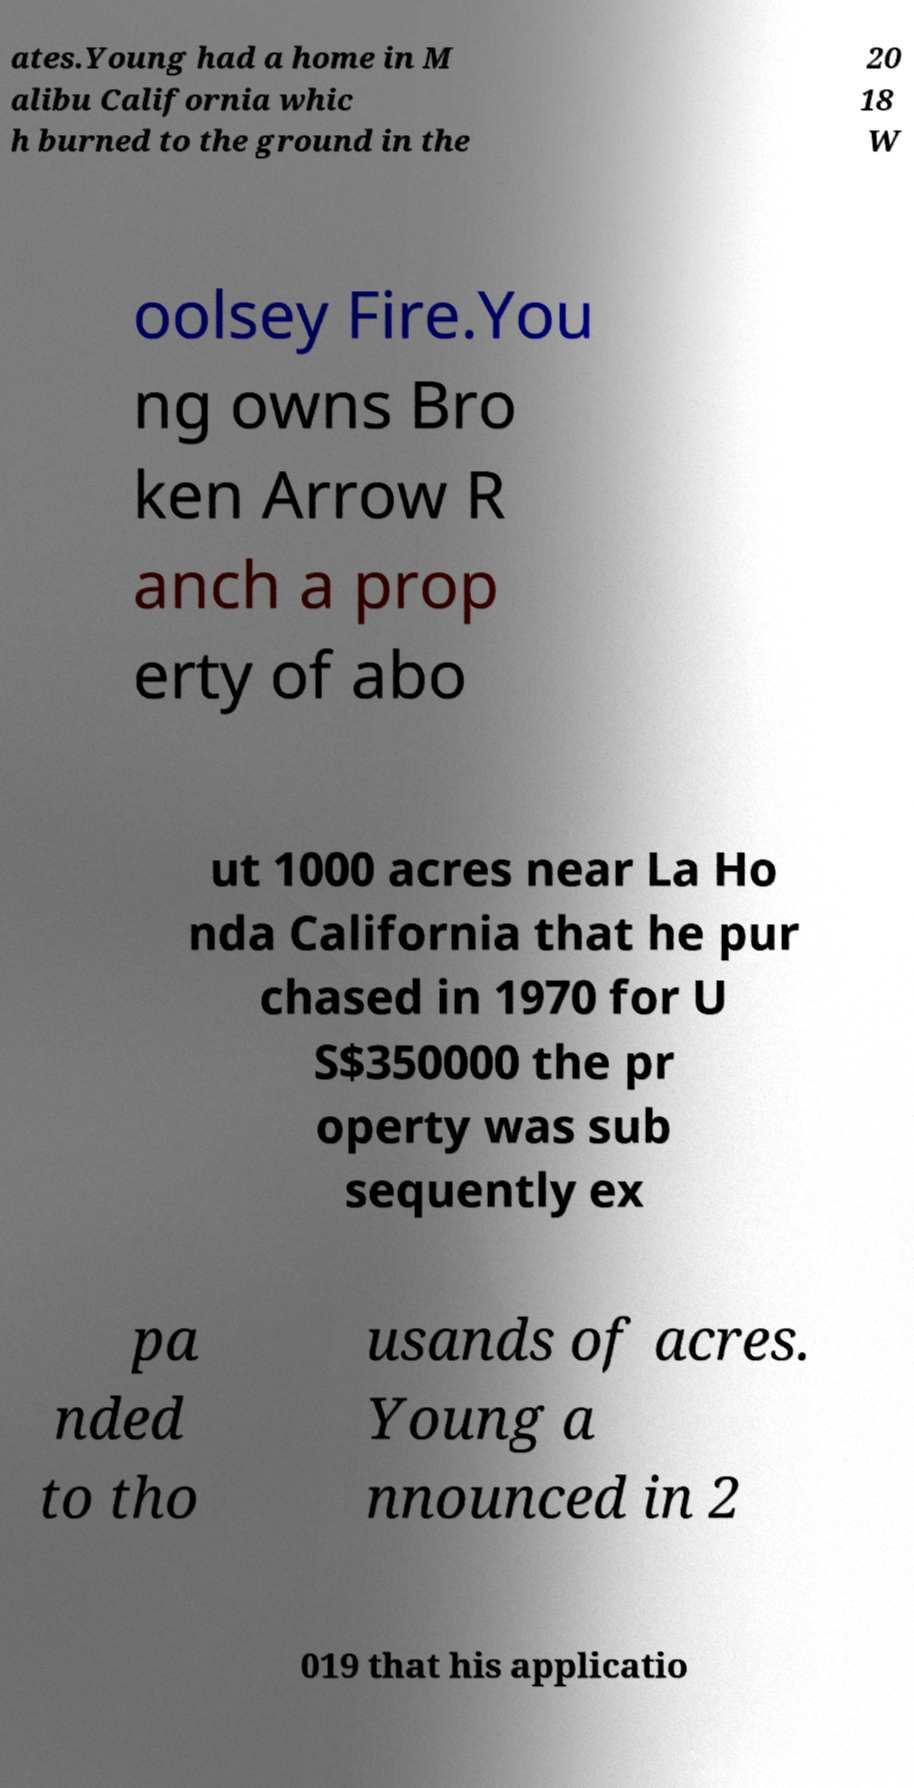Could you assist in decoding the text presented in this image and type it out clearly? ates.Young had a home in M alibu California whic h burned to the ground in the 20 18 W oolsey Fire.You ng owns Bro ken Arrow R anch a prop erty of abo ut 1000 acres near La Ho nda California that he pur chased in 1970 for U S$350000 the pr operty was sub sequently ex pa nded to tho usands of acres. Young a nnounced in 2 019 that his applicatio 